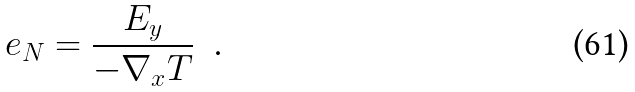<formula> <loc_0><loc_0><loc_500><loc_500>e _ { N } = \frac { E _ { y } } { - \nabla _ { x } T } \text { \ .}</formula> 